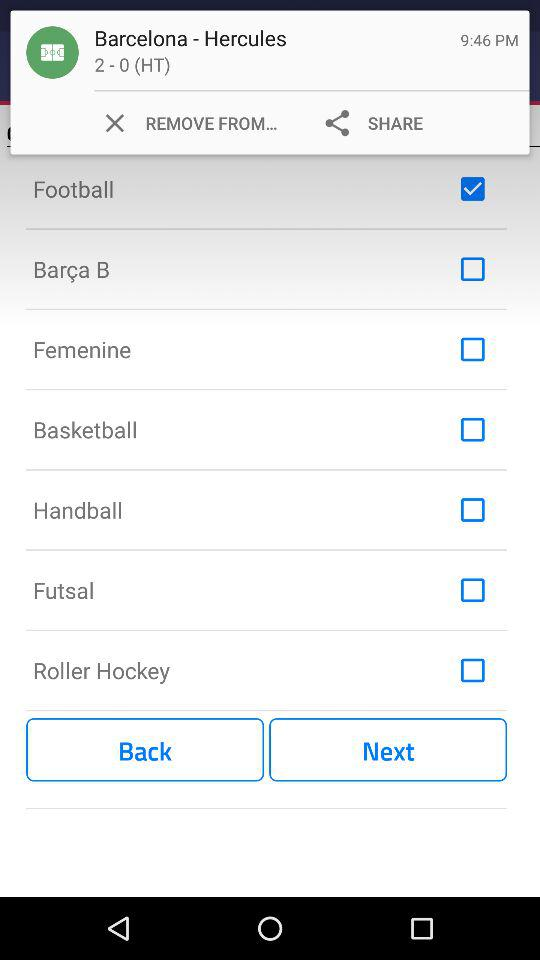What is the status of "Roller Hockey"? The status is "off". 